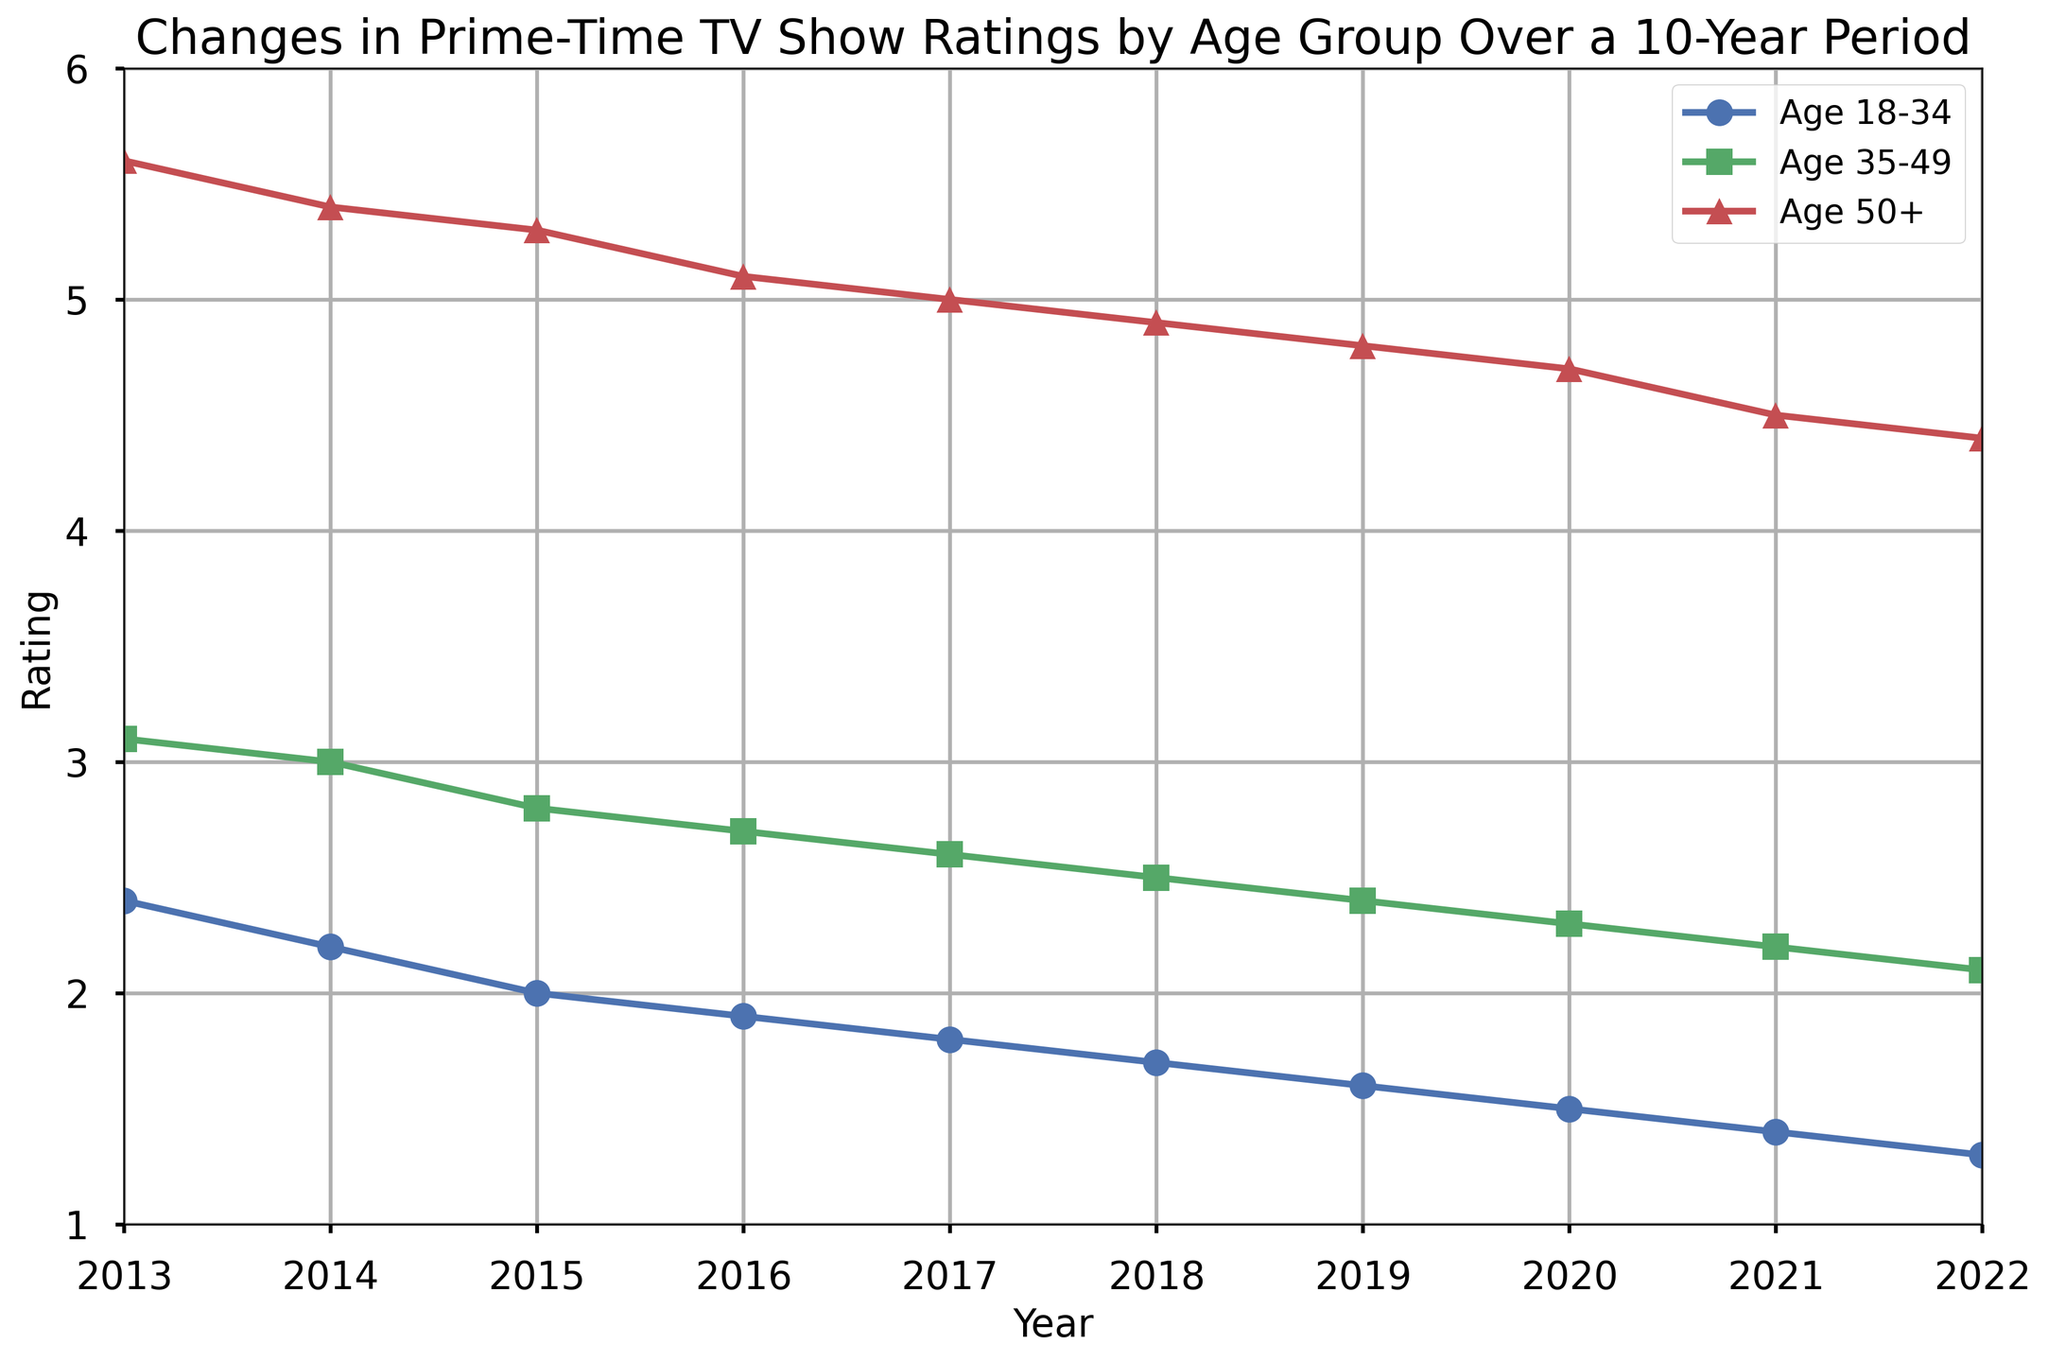Which age group has the highest rating in 2022? Look at the points for the year 2022 in each age group. The Age 50+ group has a rating of 4.4, which is higher than the ratings of Age 35-49 (2.1) and Age 18-34 (1.3).
Answer: Age 50+ Between which two years did the Age 18-34 group's ratings see the steepest decline? Calculate the differences year over year for Age 18-34. The largest difference occurs between 2013 (2.4) and 2014 (2.2), which is a decrease of 0.2.
Answer: 2013 and 2014 How much did the Age 35-49 group's rating decrease from 2013 to 2022? Subtract the 2022 rating (2.1) from the 2013 rating (3.1) for Age 35-49. The decrease is 3.1 - 2.1 = 1.0.
Answer: 1.0 What is the average rating of the Age 50+ group over the 10-year period? Sum the ratings of the Age 50+ group across all years and divide by the number of years. (5.6 + 5.4 + 5.3 + 5.1 + 5.0 + 4.9 + 4.8 + 4.7 + 4.5 + 4.4) / 10 = 4.97
Answer: 4.97 In which year did the Age 35-49 group see their rating drop below 3.0? Identify the year when the Age 35-49 group’s rating dips below 3.0 by examining the line graph. This occurs in 2015 when the rating is 2.8.
Answer: 2015 Which age group experienced the smallest overall decrease in ratings from 2013 to 2022? Calculate the decrease for each age group: Age 18-34 (2.4 - 1.3 = 1.1), Age 35-49 (3.1 - 2.1 = 1.0), and Age 50+ (5.6 - 4.4 = 1.2). The Age 35-49 group has the smallest decrease (1.0).
Answer: Age 35-49 What is the median rating of the Age 18-34 group over the 10-year period? Order the ratings for Age 18-34 and find the middle value as there are 10 values. The ordered ratings are: [1.3, 1.4, 1.5, 1.6, 1.7, 1.8, 1.9, 2.0, 2.2, 2.4]. The median is (1.8 + 1.9) / 2 = 1.85.
Answer: 1.85 